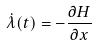<formula> <loc_0><loc_0><loc_500><loc_500>\dot { \lambda } ( t ) = - \frac { \partial H } { \partial x }</formula> 